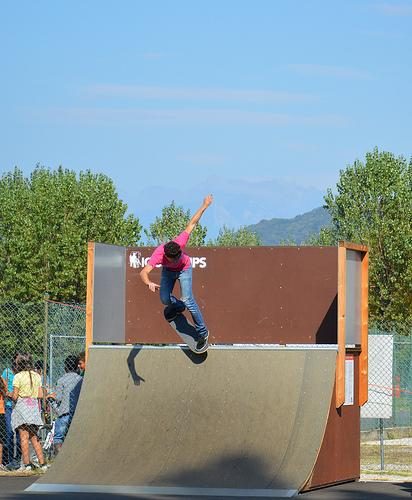Identify the main action happening in the image and the person involved in it. A skateboarder is performing a trick on a ramp wearing a pink shirt and blue jeans with a hole. Describe the image by focusing on the colors present. The skateboarder wears a pink shirt and blue jeans while performing on the brown ramp with clear blue sky above. Give a brief description of the clothing of both the main characters in the image. The skateboarder is wearing a pink shirt and blue jeans, while the girl has a yellow shirt, jeans, and a jacket around her waist. Explain the environment and setting of the image. The scene takes place at a skate park with a brown skateboard ramp, a gray fence, green trees, and clear blue sky. Describe the image by mentioning the people who are present in the background. People can be seen standing behind a fence while observing the skateboarder and the girl by the ramp. Explain the appearance and features of the skateboard involved in the scene. The skateboard used in the scene is black and is seen in action under the skateboarder's feet. Mention the condition of the clothing of the person performing the action. The skateboarder has a hole in his blue jeans and is wearing a pink shirt. Focus on the image and describe the ramp and its surroundings. A paved skateboard ramp is seen with a white line at the bottom, surrounded by a fence and people standing behind it. Write a sentence describing the weather and sky in the image. The weather appears to be sunny and clear, as the sky is blue without any clouds. Provide a description focusing on the female character in the image. A girl with a yellow shirt, long ponytail, and a jacket tied around her waist is standing by the ramp. 